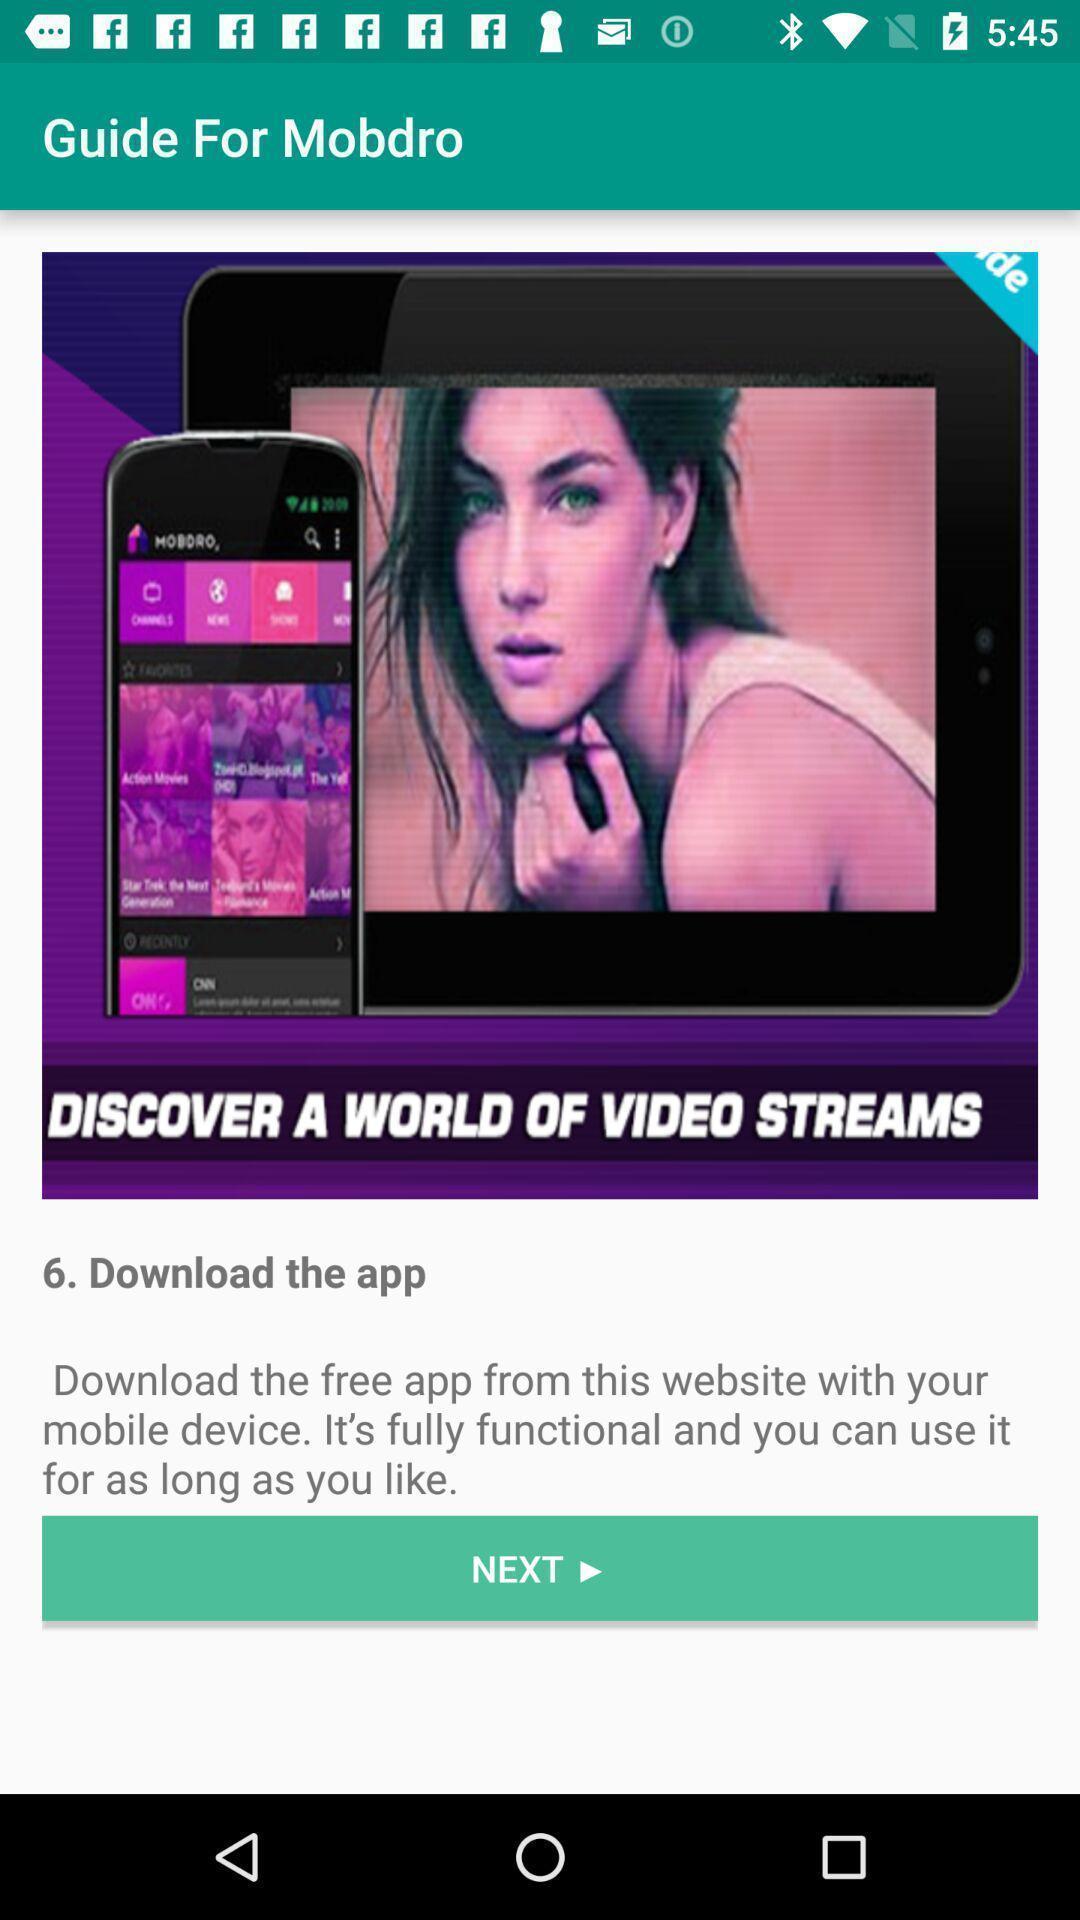What details can you identify in this image? Screen displaying the image. 